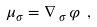<formula> <loc_0><loc_0><loc_500><loc_500>\mu _ { \sigma } = \nabla _ { \, \sigma \, } \varphi \ ,</formula> 